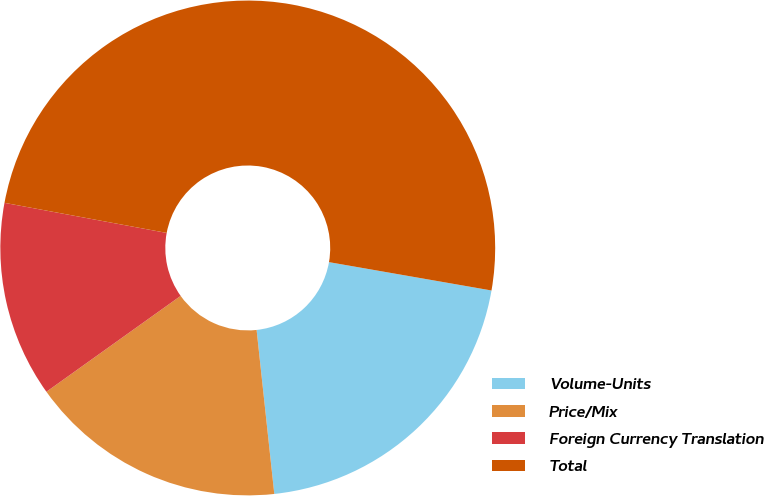Convert chart to OTSL. <chart><loc_0><loc_0><loc_500><loc_500><pie_chart><fcel>Volume-Units<fcel>Price/Mix<fcel>Foreign Currency Translation<fcel>Total<nl><fcel>20.54%<fcel>16.84%<fcel>12.79%<fcel>49.83%<nl></chart> 